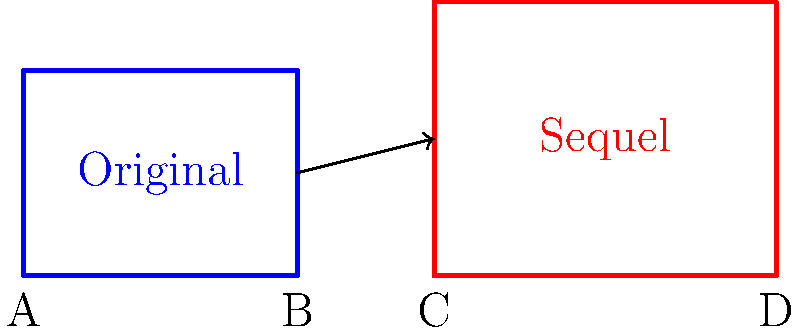In the architectural blueprints above, the iconic set from an original film is transformed for its sequel. If the area of the original set is 12 square meters, what is the area of the transformed set in the sequel, assuming the scale is consistent? To solve this problem, we'll follow these steps:

1. Calculate the dimensions of the original set:
   - Area of original set = 12 sq m
   - Width of original set (AB) = 4 m
   - Height of original set = Area ÷ Width = 12 ÷ 4 = 3 m

2. Determine the scale factor for the sequel set:
   - Width of sequel set (CD) = 11 - 6 = 5 m
   - Scale factor for width = 5 ÷ 4 = 1.25

3. Calculate the height of the sequel set:
   - Original height = 3 m
   - Sequel height = 3 × 1.25 = 3.75 m

4. Calculate the area of the sequel set:
   - Area = Width × Height
   - Area = 5 m × 3.75 m = 18.75 sq m

Therefore, the area of the transformed set in the sequel is 18.75 square meters.
Answer: 18.75 sq m 